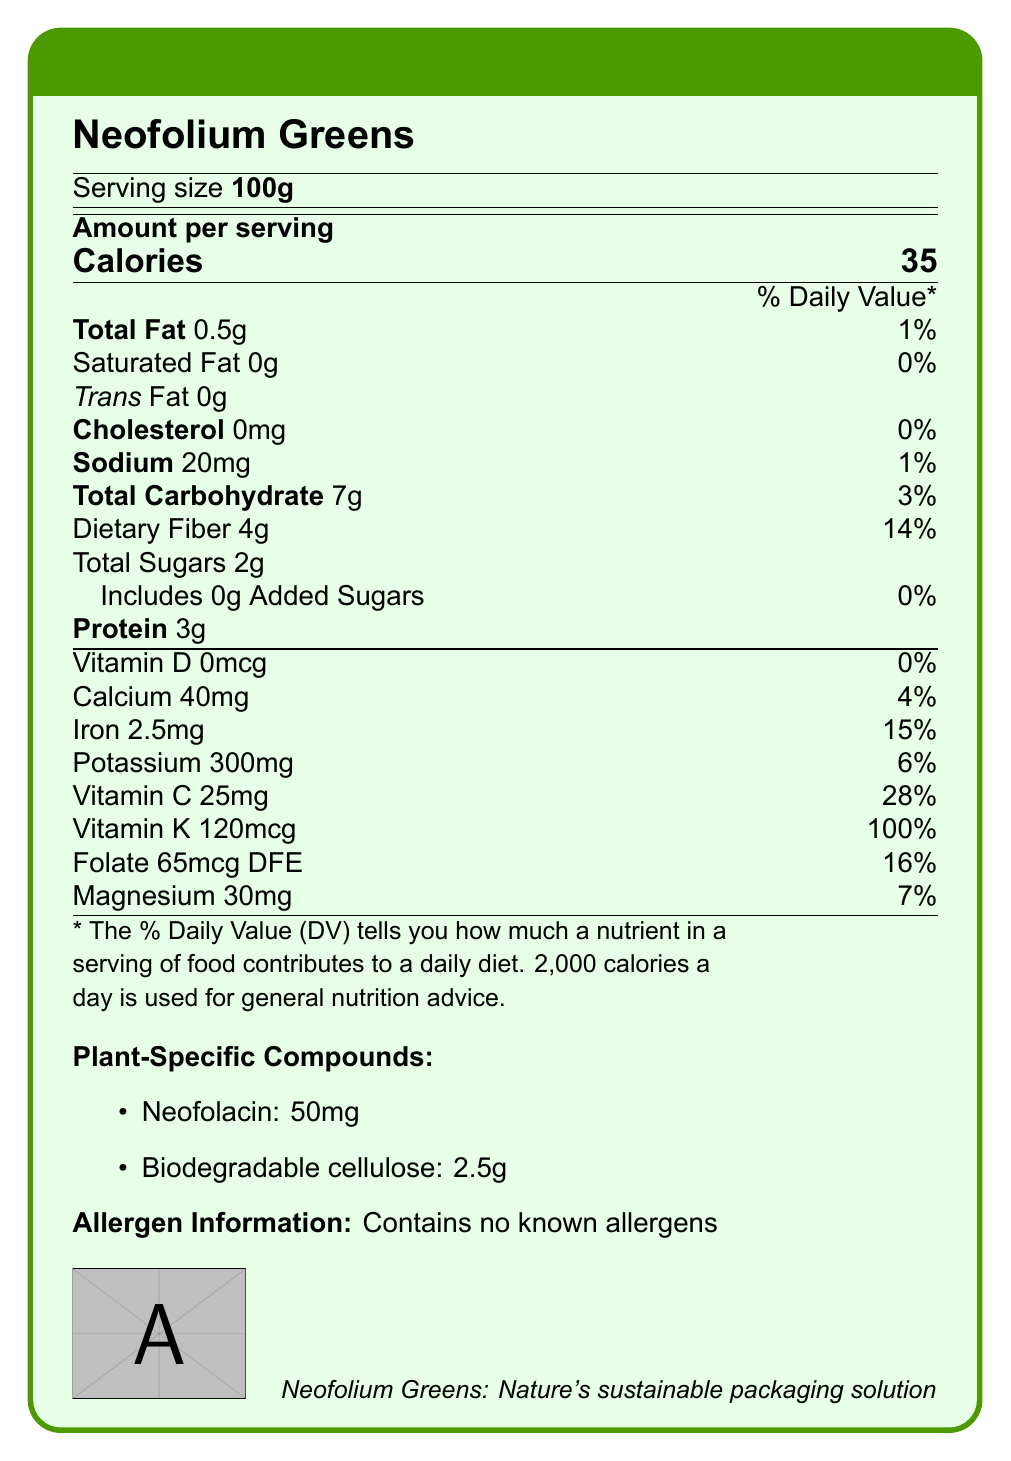what is the serving size of Neofolium Greens? The document specifies the serving size as 100g.
Answer: 100g how many calories are in one serving of Neofolium Greens? The document lists 35 calories for one serving.
Answer: 35 calories what percentage of the daily value of dietary fiber does one serving of Neofolium Greens provide? The document shows that one serving provides 14% of the daily value of dietary fiber.
Answer: 14% how much protein is in one serving of Neofolium Greens? According to the document, one serving contains 3g of protein.
Answer: 3g what is the amount of iron in one serving of Neofolium Greens? The document states that one serving contains 2.5mg of iron.
Answer: 2.5mg which plant-specific compound in Neofolium Greens has potential anti-inflammatory properties? The document mentions that Neofolacin is a unique antioxidant found in Neofolium Greens with potential anti-inflammatory properties.
Answer: Neofolacin how much biodegradable cellulose does one serving of Neofolium Greens contain? A. 0.5g B. 1g C. 2.5g D. 5g The document notes that each serving contains 2.5g of biodegradable cellulose.
Answer: C. 2.5g how much vitamin C is in one serving of Neofolium Greens? A. 10mg B. 15mg C. 20mg D. 25mg The document lists the amount of vitamin C per serving as 25mg.
Answer: D. 25mg does Neofolium Greens contain any known allergens? The document explicitly states that Neofolium Greens contains no known allergens.
Answer: No is there any added sugar in Neofolium Greens? The document indicates that there are 0g of added sugars in Neofolium Greens.
Answer: No is Neofolium Greens high in saturated fat? The document shows that Neofolium Greens contains 0g of saturated fat.
Answer: No what are the potential sustainable uses of Neofolium Greens? The document mentions that Neofolium Greens can be used for both food and developing biodegradable food packaging materials.
Answer: Food and biodegradable packaging can the exact method of cultivating Neofolium Greens be determined from the document? The document only notes that Neofolium Greens thrive in temperate climates and can be sustainably harvested three times a year, but it does not provide specific details on the cultivation method.
Answer: Not enough information what is the main idea of the document? The document details the nutritional content per 100g serving of Neofolium Greens, its unique plant-specific compounds, allergen information, potential uses in sustainable packaging, and notes on its cultivation and sustainability impact.
Answer: The document provides nutritional information on Neofolium Greens, highlighting its potential benefits both as a nutritious food source and a sustainable packaging material. what percentage of the daily value of vitamin K does Neofolium Greens provide? The document indicates that one serving provides 100% of the daily value of vitamin K.
Answer: 100% 